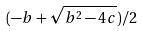<formula> <loc_0><loc_0><loc_500><loc_500>( - b + \sqrt { b ^ { 2 } - 4 c } ) / 2</formula> 